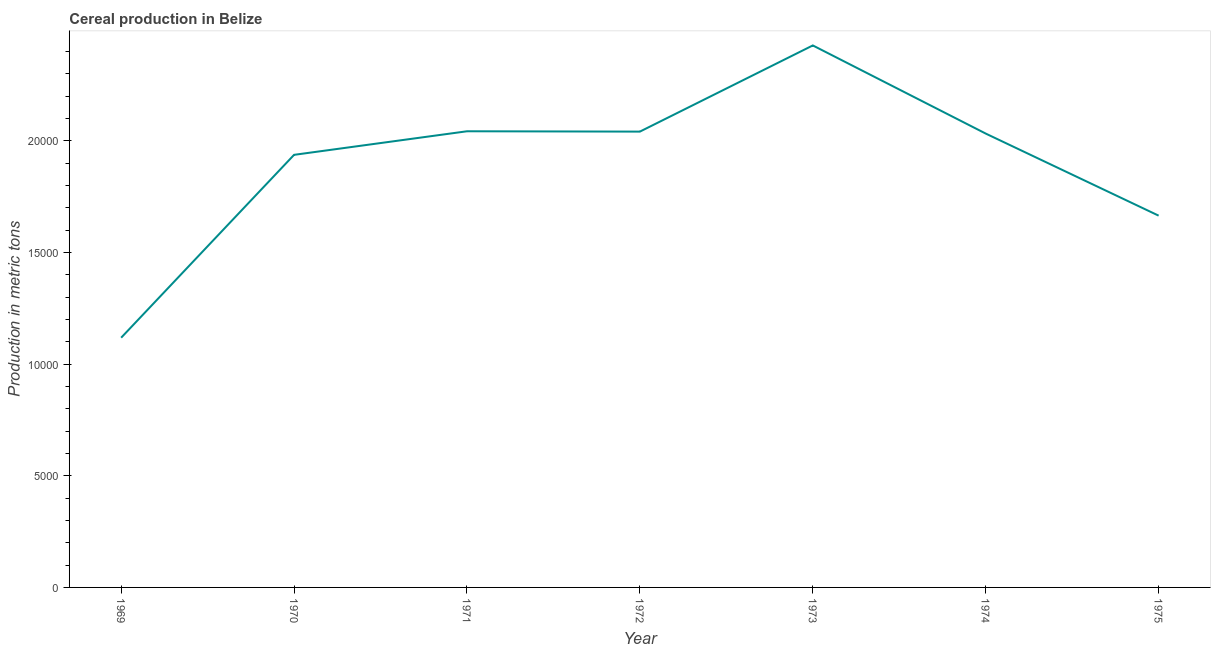What is the cereal production in 1972?
Your response must be concise. 2.04e+04. Across all years, what is the maximum cereal production?
Provide a short and direct response. 2.43e+04. Across all years, what is the minimum cereal production?
Make the answer very short. 1.12e+04. In which year was the cereal production maximum?
Ensure brevity in your answer.  1973. In which year was the cereal production minimum?
Make the answer very short. 1969. What is the sum of the cereal production?
Your response must be concise. 1.33e+05. What is the difference between the cereal production in 1972 and 1973?
Give a very brief answer. -3858. What is the average cereal production per year?
Your response must be concise. 1.89e+04. What is the median cereal production?
Your answer should be compact. 2.03e+04. In how many years, is the cereal production greater than 14000 metric tons?
Your response must be concise. 6. What is the ratio of the cereal production in 1969 to that in 1972?
Offer a very short reply. 0.55. Is the cereal production in 1969 less than that in 1972?
Ensure brevity in your answer.  Yes. Is the difference between the cereal production in 1971 and 1972 greater than the difference between any two years?
Your response must be concise. No. What is the difference between the highest and the second highest cereal production?
Make the answer very short. 3843. What is the difference between the highest and the lowest cereal production?
Make the answer very short. 1.31e+04. How many lines are there?
Your answer should be very brief. 1. How many years are there in the graph?
Offer a very short reply. 7. Are the values on the major ticks of Y-axis written in scientific E-notation?
Your answer should be compact. No. Does the graph contain any zero values?
Your response must be concise. No. Does the graph contain grids?
Provide a succinct answer. No. What is the title of the graph?
Keep it short and to the point. Cereal production in Belize. What is the label or title of the Y-axis?
Your response must be concise. Production in metric tons. What is the Production in metric tons in 1969?
Your answer should be compact. 1.12e+04. What is the Production in metric tons of 1970?
Your answer should be very brief. 1.94e+04. What is the Production in metric tons of 1971?
Provide a succinct answer. 2.04e+04. What is the Production in metric tons of 1972?
Keep it short and to the point. 2.04e+04. What is the Production in metric tons in 1973?
Offer a terse response. 2.43e+04. What is the Production in metric tons of 1974?
Ensure brevity in your answer.  2.03e+04. What is the Production in metric tons of 1975?
Keep it short and to the point. 1.66e+04. What is the difference between the Production in metric tons in 1969 and 1970?
Give a very brief answer. -8188. What is the difference between the Production in metric tons in 1969 and 1971?
Provide a short and direct response. -9243. What is the difference between the Production in metric tons in 1969 and 1972?
Offer a terse response. -9228. What is the difference between the Production in metric tons in 1969 and 1973?
Offer a very short reply. -1.31e+04. What is the difference between the Production in metric tons in 1969 and 1974?
Keep it short and to the point. -9140. What is the difference between the Production in metric tons in 1969 and 1975?
Provide a short and direct response. -5465. What is the difference between the Production in metric tons in 1970 and 1971?
Your answer should be compact. -1055. What is the difference between the Production in metric tons in 1970 and 1972?
Your answer should be very brief. -1040. What is the difference between the Production in metric tons in 1970 and 1973?
Offer a very short reply. -4898. What is the difference between the Production in metric tons in 1970 and 1974?
Your response must be concise. -952. What is the difference between the Production in metric tons in 1970 and 1975?
Make the answer very short. 2723. What is the difference between the Production in metric tons in 1971 and 1972?
Provide a short and direct response. 15. What is the difference between the Production in metric tons in 1971 and 1973?
Make the answer very short. -3843. What is the difference between the Production in metric tons in 1971 and 1974?
Keep it short and to the point. 103. What is the difference between the Production in metric tons in 1971 and 1975?
Offer a terse response. 3778. What is the difference between the Production in metric tons in 1972 and 1973?
Ensure brevity in your answer.  -3858. What is the difference between the Production in metric tons in 1972 and 1974?
Make the answer very short. 88. What is the difference between the Production in metric tons in 1972 and 1975?
Your answer should be compact. 3763. What is the difference between the Production in metric tons in 1973 and 1974?
Provide a succinct answer. 3946. What is the difference between the Production in metric tons in 1973 and 1975?
Offer a very short reply. 7621. What is the difference between the Production in metric tons in 1974 and 1975?
Make the answer very short. 3675. What is the ratio of the Production in metric tons in 1969 to that in 1970?
Your response must be concise. 0.58. What is the ratio of the Production in metric tons in 1969 to that in 1971?
Give a very brief answer. 0.55. What is the ratio of the Production in metric tons in 1969 to that in 1972?
Offer a terse response. 0.55. What is the ratio of the Production in metric tons in 1969 to that in 1973?
Your answer should be compact. 0.46. What is the ratio of the Production in metric tons in 1969 to that in 1974?
Your answer should be very brief. 0.55. What is the ratio of the Production in metric tons in 1969 to that in 1975?
Provide a short and direct response. 0.67. What is the ratio of the Production in metric tons in 1970 to that in 1971?
Your response must be concise. 0.95. What is the ratio of the Production in metric tons in 1970 to that in 1972?
Your response must be concise. 0.95. What is the ratio of the Production in metric tons in 1970 to that in 1973?
Make the answer very short. 0.8. What is the ratio of the Production in metric tons in 1970 to that in 1974?
Your response must be concise. 0.95. What is the ratio of the Production in metric tons in 1970 to that in 1975?
Your answer should be very brief. 1.16. What is the ratio of the Production in metric tons in 1971 to that in 1973?
Keep it short and to the point. 0.84. What is the ratio of the Production in metric tons in 1971 to that in 1975?
Provide a short and direct response. 1.23. What is the ratio of the Production in metric tons in 1972 to that in 1973?
Your answer should be very brief. 0.84. What is the ratio of the Production in metric tons in 1972 to that in 1974?
Offer a terse response. 1. What is the ratio of the Production in metric tons in 1972 to that in 1975?
Your answer should be compact. 1.23. What is the ratio of the Production in metric tons in 1973 to that in 1974?
Ensure brevity in your answer.  1.19. What is the ratio of the Production in metric tons in 1973 to that in 1975?
Provide a succinct answer. 1.46. What is the ratio of the Production in metric tons in 1974 to that in 1975?
Offer a terse response. 1.22. 